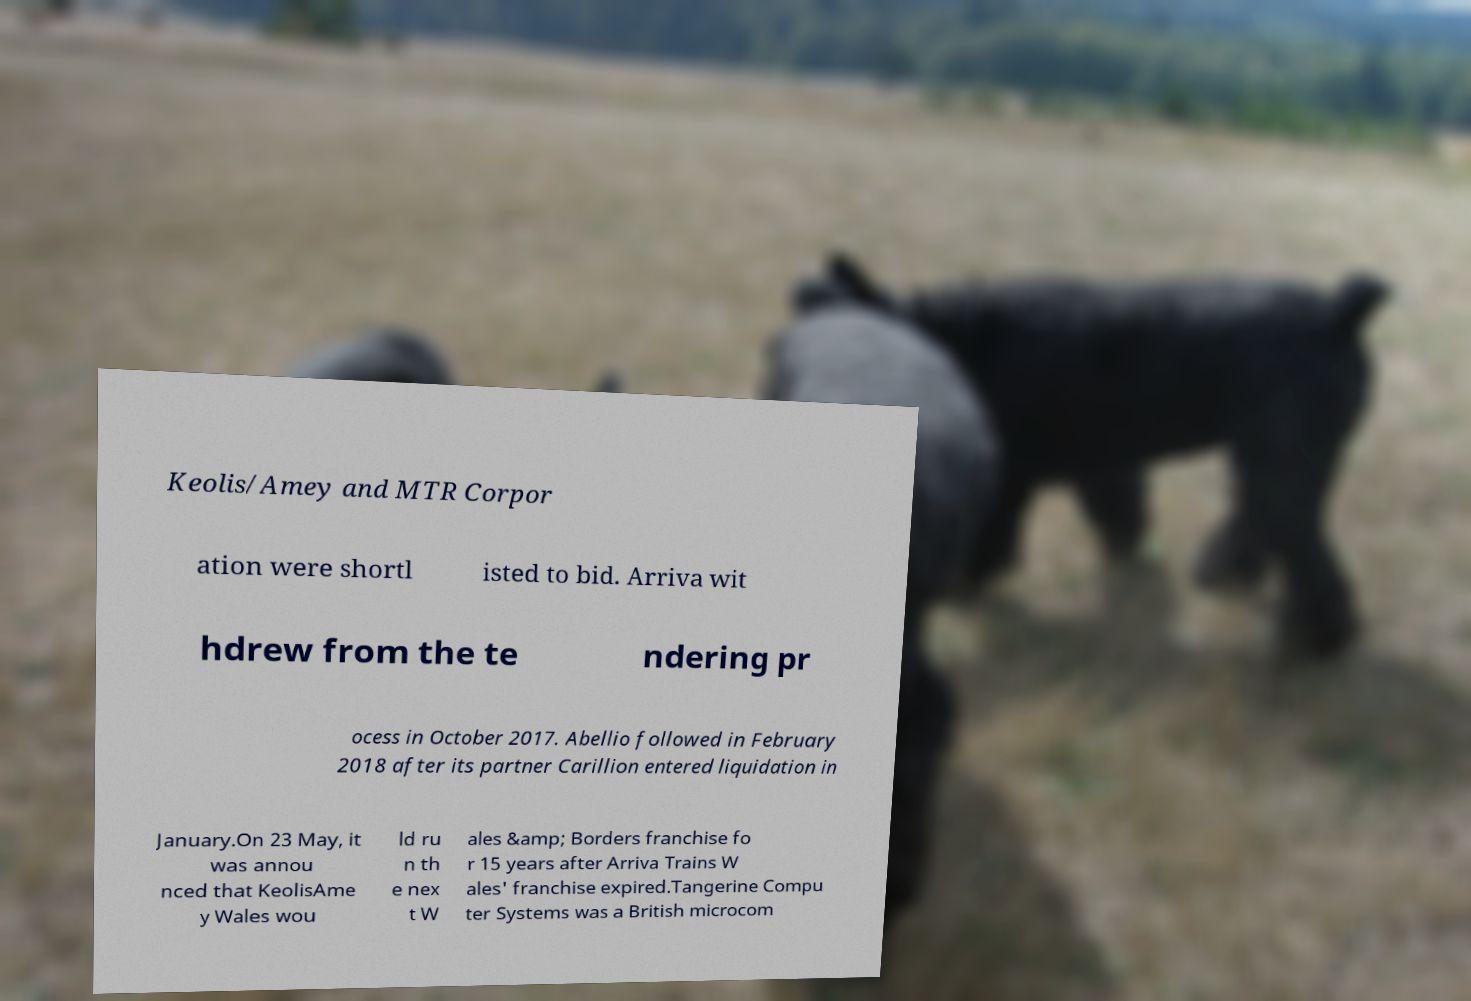Could you extract and type out the text from this image? Keolis/Amey and MTR Corpor ation were shortl isted to bid. Arriva wit hdrew from the te ndering pr ocess in October 2017. Abellio followed in February 2018 after its partner Carillion entered liquidation in January.On 23 May, it was annou nced that KeolisAme y Wales wou ld ru n th e nex t W ales &amp; Borders franchise fo r 15 years after Arriva Trains W ales' franchise expired.Tangerine Compu ter Systems was a British microcom 